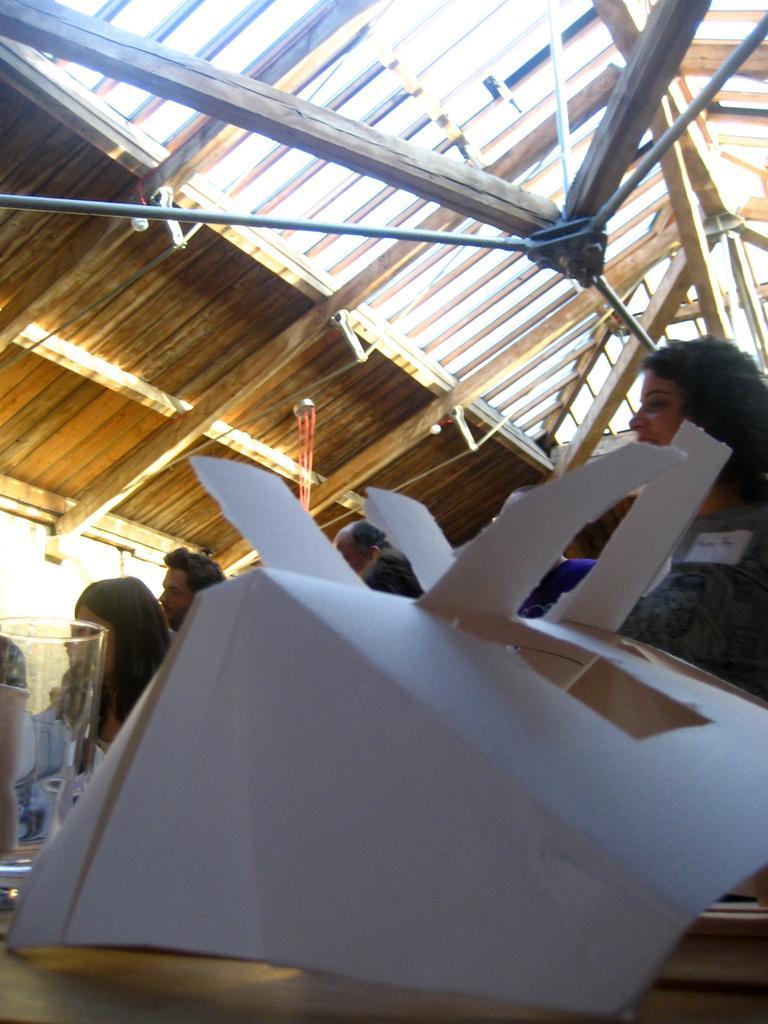Can you describe this image briefly? In the picture we can see a desk on it, we can see a paper craft beside it, we can see a glass and behind we can see some people are standing and some are sitting and to the ceiling we can see a wooden plank and some iron poles fixed to it. 